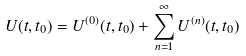Convert formula to latex. <formula><loc_0><loc_0><loc_500><loc_500>U ( t , t _ { 0 } ) = U ^ { ( 0 ) } ( t , t _ { 0 } ) + \sum _ { n = 1 } ^ { \infty } U ^ { ( n ) } ( t , t _ { 0 } )</formula> 